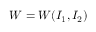Convert formula to latex. <formula><loc_0><loc_0><loc_500><loc_500>W = W ( I _ { 1 } , I _ { 2 } )</formula> 